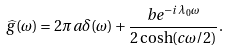<formula> <loc_0><loc_0><loc_500><loc_500>\widehat { g } ( \omega ) = 2 \pi a \delta ( \omega ) + \frac { b e ^ { - i \lambda _ { 0 } \omega } } { 2 \cosh ( c \omega / 2 ) } .</formula> 